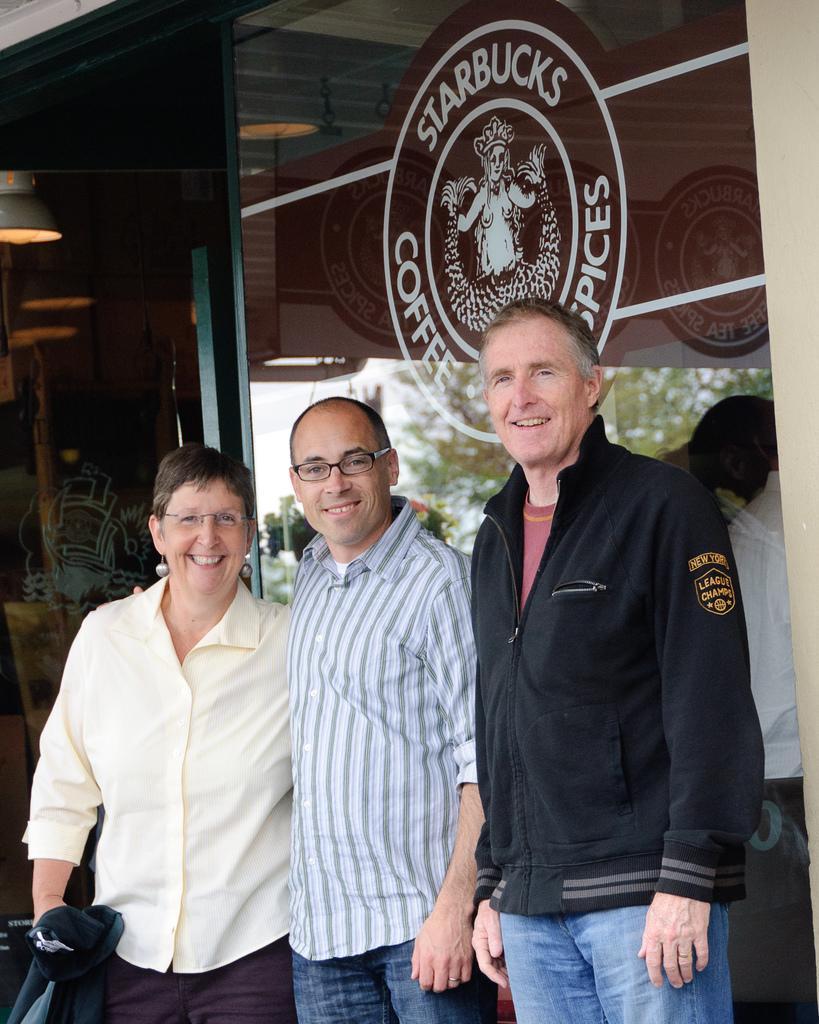In one or two sentences, can you explain what this image depicts? In this picture there are group of people standing and smiling. At the back there is a building and there is a text and there is a logo on the mirror and there are lights inside the room. There is reflection of sky and tree on the mirror. 